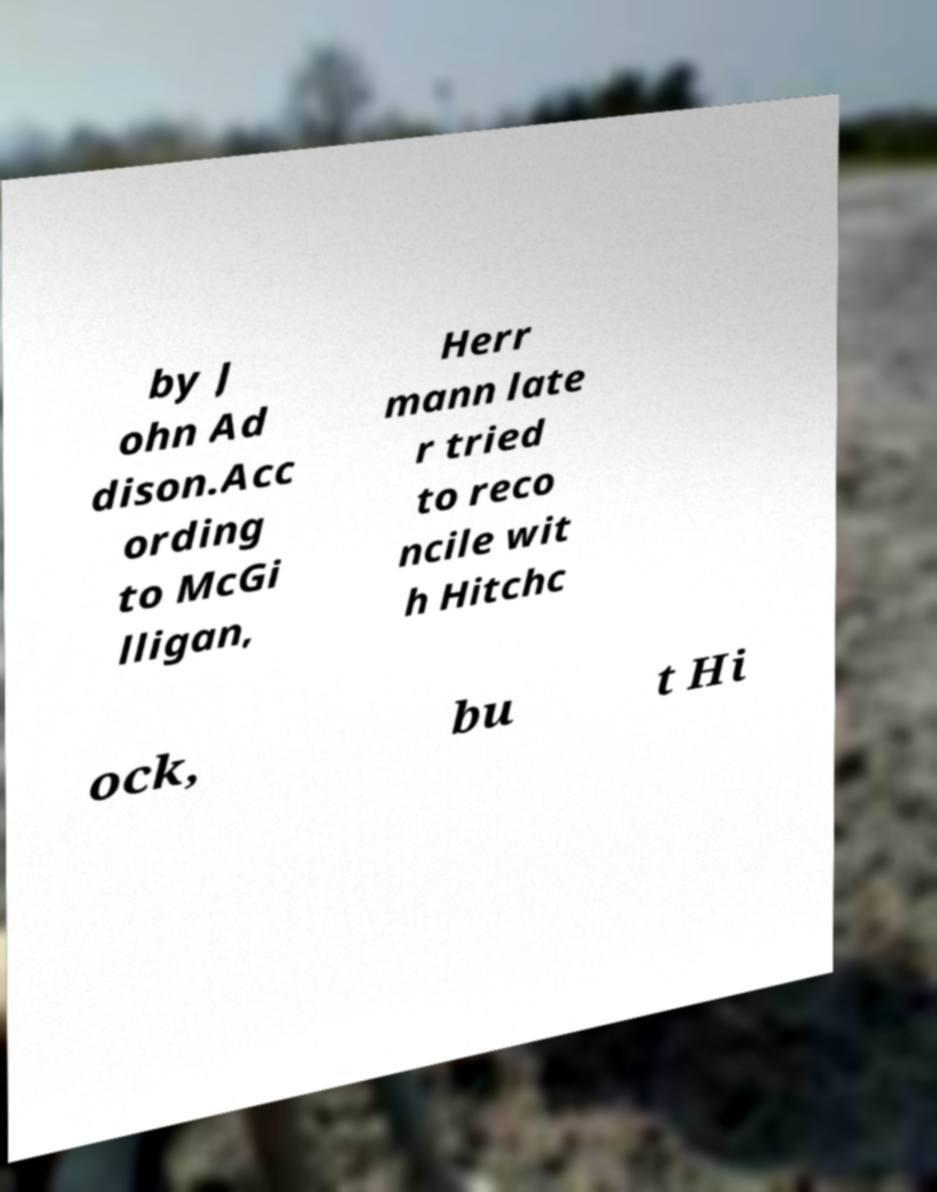There's text embedded in this image that I need extracted. Can you transcribe it verbatim? by J ohn Ad dison.Acc ording to McGi lligan, Herr mann late r tried to reco ncile wit h Hitchc ock, bu t Hi 